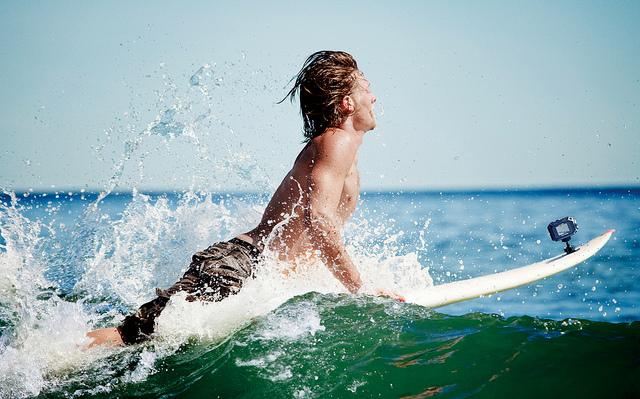Is the surfer concentrating?
Quick response, please. Yes. What color are the man's shorts?
Concise answer only. Brown. Is the man impersonating The Little Mermaid scene where Ariel comes out of the water?
Give a very brief answer. No. Did he hop off the wave?
Write a very short answer. No. How old is this guy?
Give a very brief answer. 23. Is this a big wave?
Write a very short answer. No. Is this guy snowboarding?
Short answer required. No. 